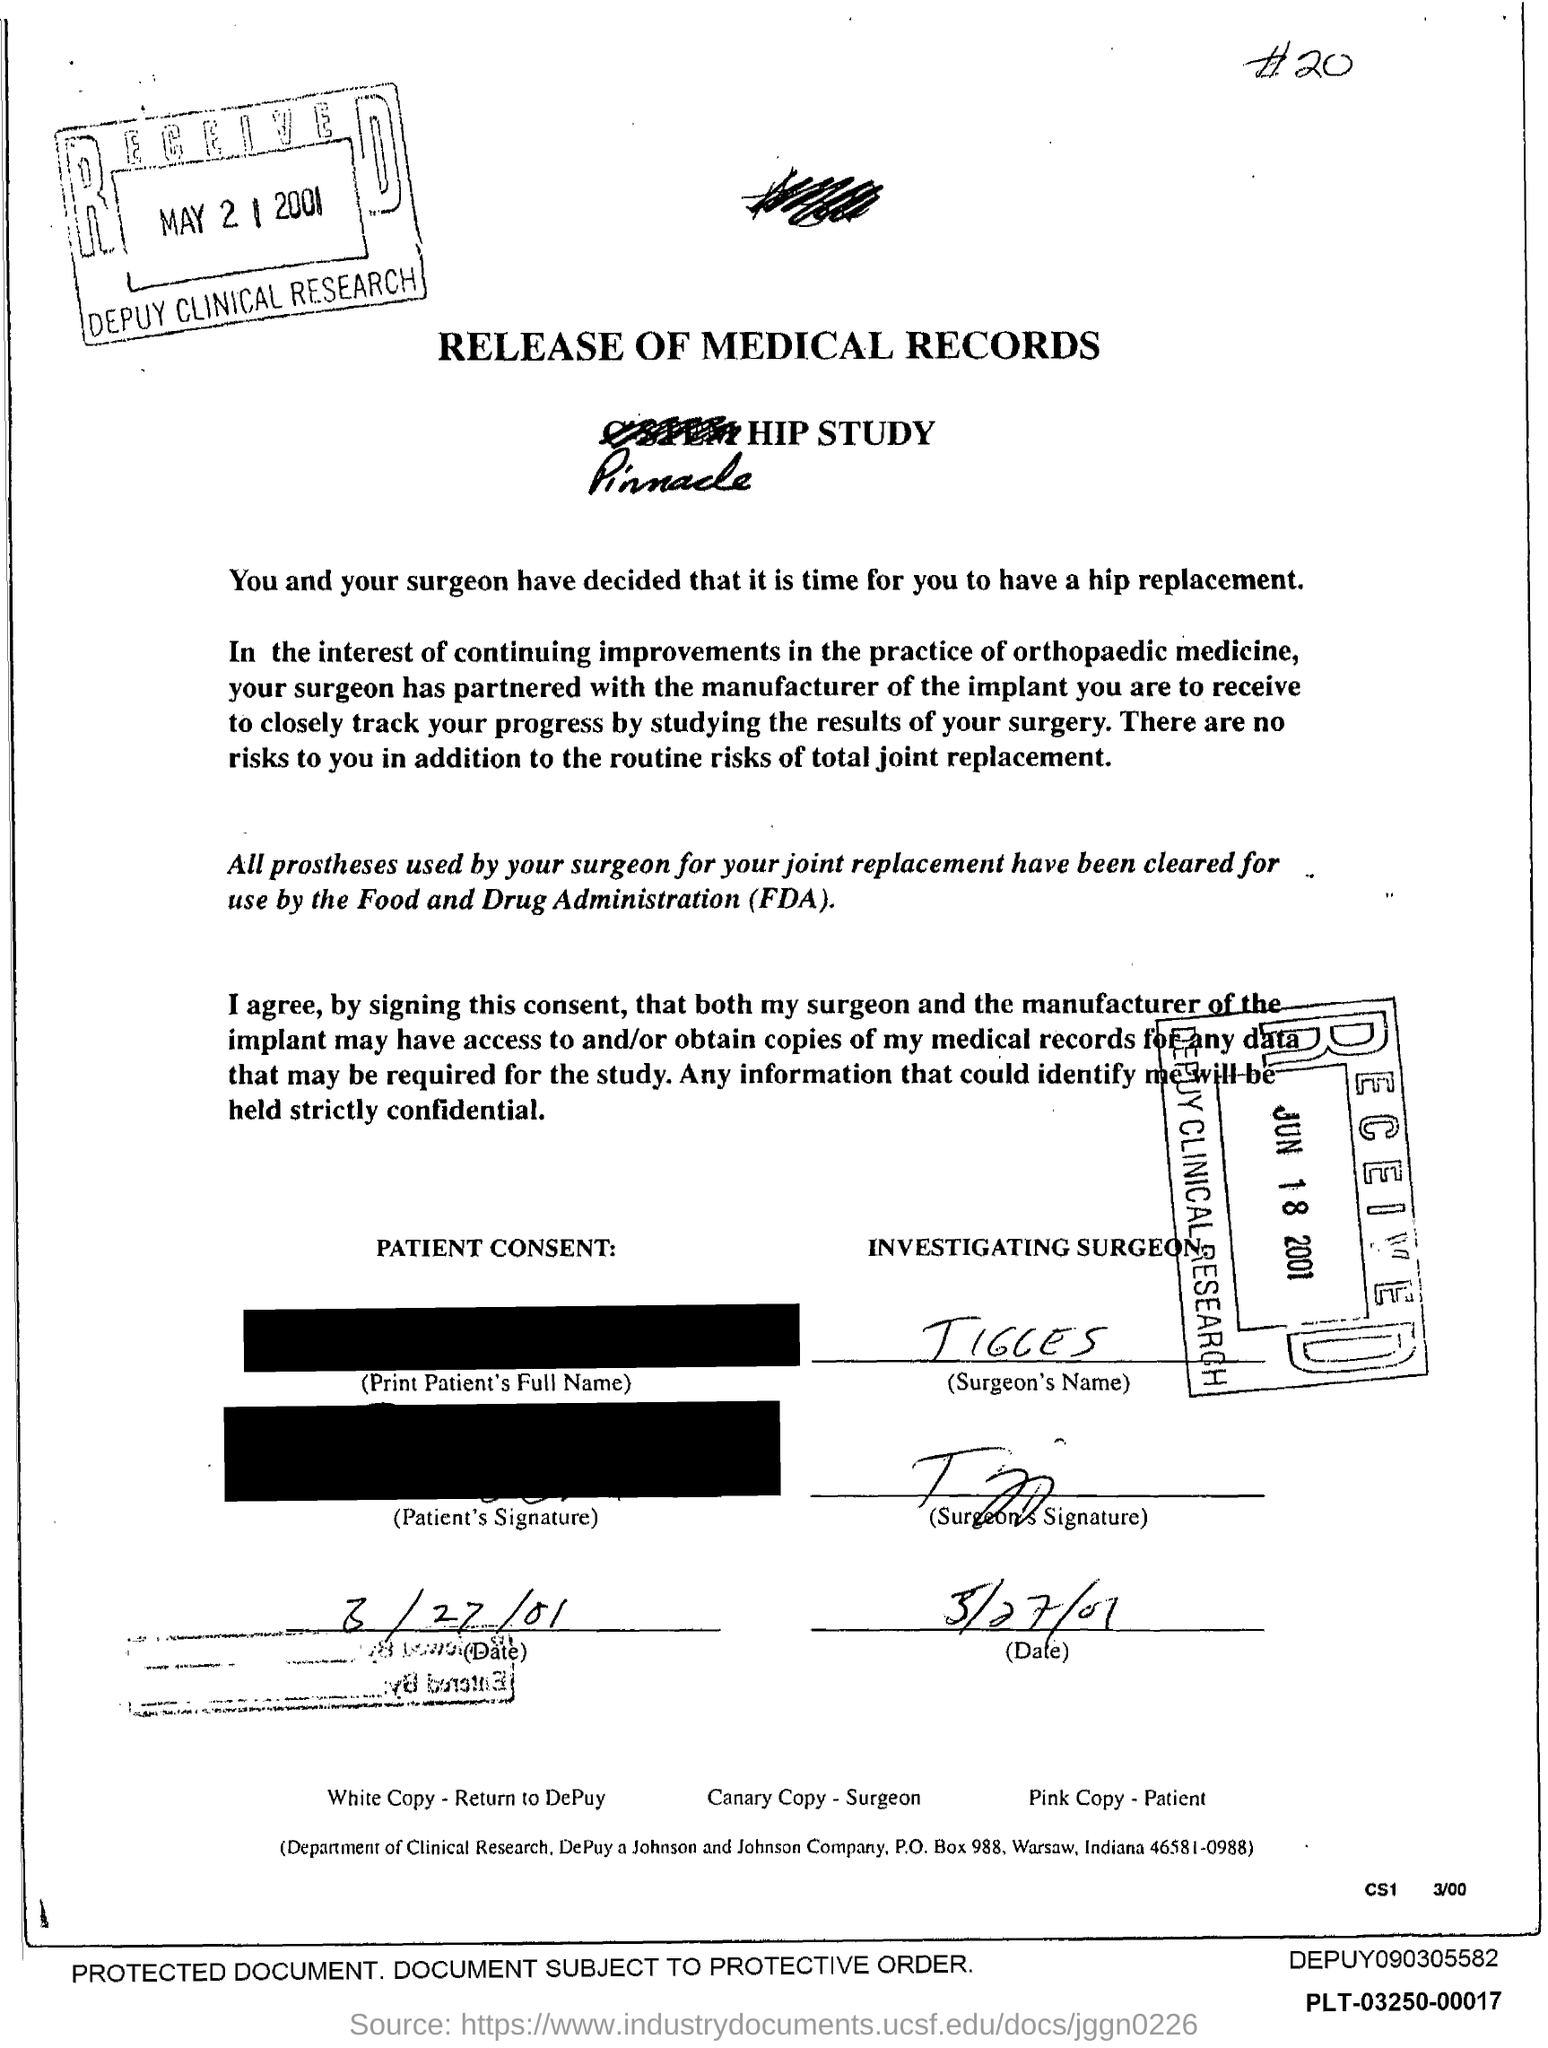Who is the Investigating surgeon?
Offer a terse response. Tigges. What is the title of the document?
Your response must be concise. Release of Medical Records. 